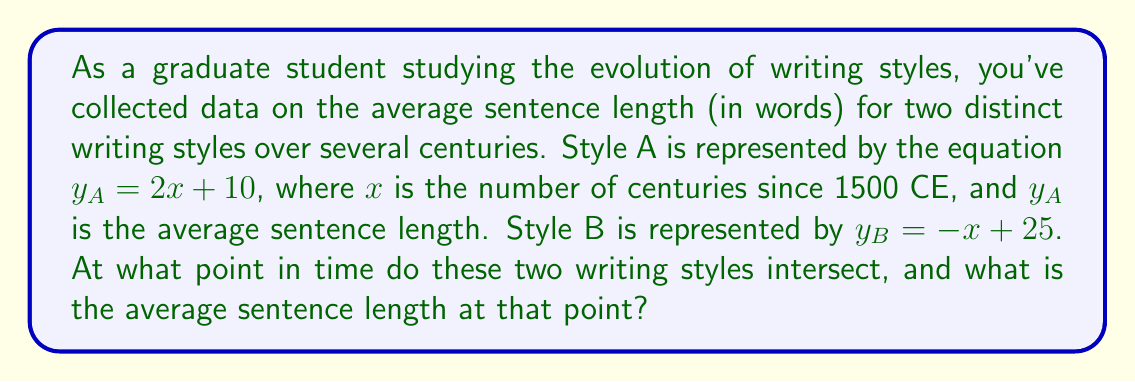Teach me how to tackle this problem. To solve this problem, we need to find the intersection point of the two linear equations representing the writing styles. This can be done by setting the equations equal to each other and solving for $x$.

1) Set the equations equal:
   $y_A = y_B$
   $2x + 10 = -x + 25$

2) Solve for $x$:
   $2x + 10 = -x + 25$
   $3x = 15$
   $x = 5$

3) This means the styles intersect 5 centuries after 1500 CE, which is the year 2000 CE.

4) To find the average sentence length at the intersection point, substitute $x = 5$ into either equation:

   $y_A = 2(5) + 10 = 20$
   or
   $y_B = -5 + 25 = 20$

5) Therefore, the average sentence length at the intersection point is 20 words.

To visualize this:

[asy]
import graph;
size(200,200);
real f(real x) {return 2x + 10;}
real g(real x) {return -x + 25;}
xaxis("Centuries since 1500 CE",0,10,Arrow);
yaxis("Average sentence length",0,30,Arrow);
draw(graph(f,0,10),blue);
draw(graph(g,0,10),red);
dot((5,20));
label("(5, 20)",(5,20),NE);
label("Style A",(-0.5,20),W,blue);
label("Style B",(8,17),E,red);
[/asy]
Answer: The two writing styles intersect in the year 2000 CE (5 centuries after 1500 CE) with an average sentence length of 20 words. 